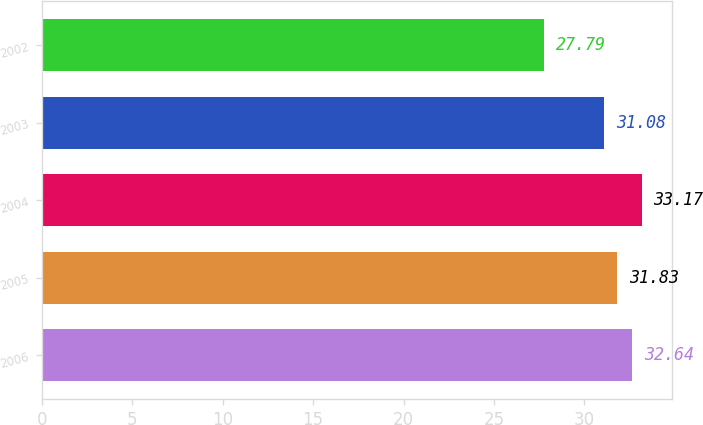Convert chart to OTSL. <chart><loc_0><loc_0><loc_500><loc_500><bar_chart><fcel>2006<fcel>2005<fcel>2004<fcel>2003<fcel>2002<nl><fcel>32.64<fcel>31.83<fcel>33.17<fcel>31.08<fcel>27.79<nl></chart> 